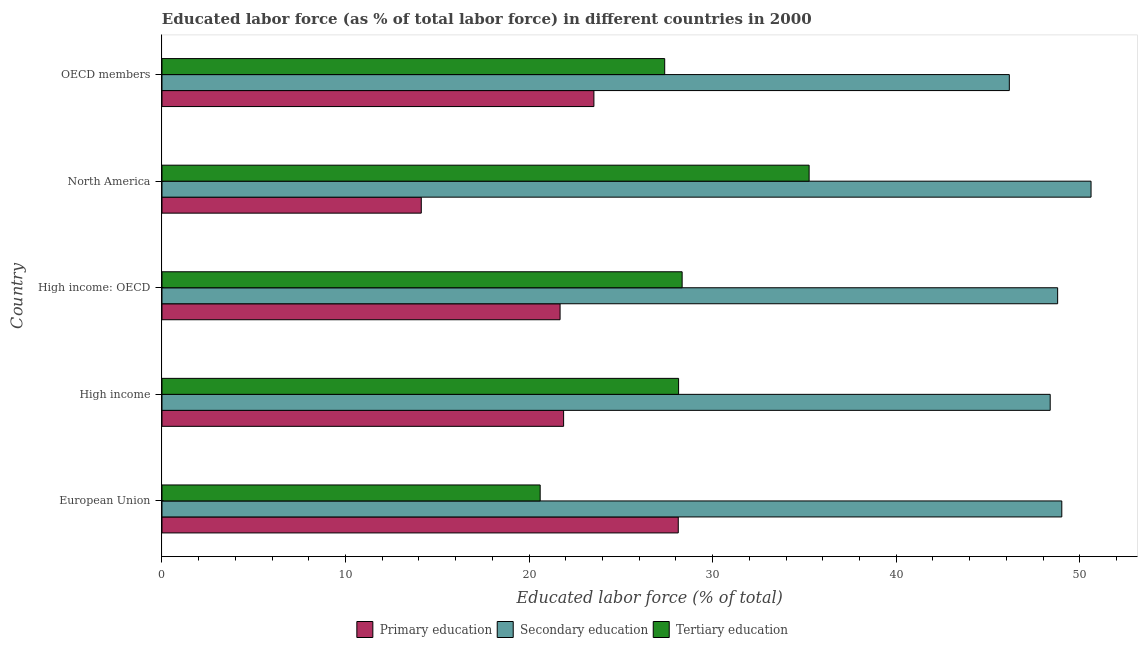How many different coloured bars are there?
Make the answer very short. 3. Are the number of bars per tick equal to the number of legend labels?
Your answer should be very brief. Yes. How many bars are there on the 3rd tick from the bottom?
Provide a short and direct response. 3. What is the percentage of labor force who received secondary education in High income: OECD?
Your response must be concise. 48.8. Across all countries, what is the maximum percentage of labor force who received primary education?
Ensure brevity in your answer.  28.13. Across all countries, what is the minimum percentage of labor force who received tertiary education?
Offer a terse response. 20.6. In which country was the percentage of labor force who received primary education minimum?
Offer a terse response. North America. What is the total percentage of labor force who received tertiary education in the graph?
Give a very brief answer. 139.73. What is the difference between the percentage of labor force who received tertiary education in European Union and that in North America?
Offer a very short reply. -14.65. What is the difference between the percentage of labor force who received secondary education in High income: OECD and the percentage of labor force who received primary education in OECD members?
Your response must be concise. 25.27. What is the average percentage of labor force who received primary education per country?
Offer a terse response. 21.87. What is the difference between the percentage of labor force who received primary education and percentage of labor force who received secondary education in North America?
Provide a succinct answer. -36.49. What is the ratio of the percentage of labor force who received tertiary education in High income to that in OECD members?
Provide a succinct answer. 1.03. Is the percentage of labor force who received secondary education in High income less than that in North America?
Your response must be concise. Yes. What is the difference between the highest and the second highest percentage of labor force who received tertiary education?
Your response must be concise. 6.92. What is the difference between the highest and the lowest percentage of labor force who received secondary education?
Give a very brief answer. 4.45. In how many countries, is the percentage of labor force who received secondary education greater than the average percentage of labor force who received secondary education taken over all countries?
Your response must be concise. 3. Is the sum of the percentage of labor force who received tertiary education in European Union and High income: OECD greater than the maximum percentage of labor force who received primary education across all countries?
Provide a succinct answer. Yes. What does the 2nd bar from the top in High income: OECD represents?
Ensure brevity in your answer.  Secondary education. What does the 3rd bar from the bottom in OECD members represents?
Keep it short and to the point. Tertiary education. How many bars are there?
Keep it short and to the point. 15. How many countries are there in the graph?
Keep it short and to the point. 5. Does the graph contain grids?
Your answer should be very brief. No. Where does the legend appear in the graph?
Your answer should be compact. Bottom center. How are the legend labels stacked?
Ensure brevity in your answer.  Horizontal. What is the title of the graph?
Ensure brevity in your answer.  Educated labor force (as % of total labor force) in different countries in 2000. What is the label or title of the X-axis?
Ensure brevity in your answer.  Educated labor force (% of total). What is the Educated labor force (% of total) in Primary education in European Union?
Offer a very short reply. 28.13. What is the Educated labor force (% of total) of Secondary education in European Union?
Provide a succinct answer. 49.02. What is the Educated labor force (% of total) of Tertiary education in European Union?
Offer a terse response. 20.6. What is the Educated labor force (% of total) of Primary education in High income?
Give a very brief answer. 21.88. What is the Educated labor force (% of total) in Secondary education in High income?
Offer a very short reply. 48.39. What is the Educated labor force (% of total) of Tertiary education in High income?
Your answer should be compact. 28.15. What is the Educated labor force (% of total) in Primary education in High income: OECD?
Your answer should be very brief. 21.69. What is the Educated labor force (% of total) of Secondary education in High income: OECD?
Offer a very short reply. 48.8. What is the Educated labor force (% of total) of Tertiary education in High income: OECD?
Give a very brief answer. 28.34. What is the Educated labor force (% of total) of Primary education in North America?
Your response must be concise. 14.13. What is the Educated labor force (% of total) in Secondary education in North America?
Your answer should be very brief. 50.62. What is the Educated labor force (% of total) of Tertiary education in North America?
Offer a terse response. 35.26. What is the Educated labor force (% of total) in Primary education in OECD members?
Offer a very short reply. 23.53. What is the Educated labor force (% of total) in Secondary education in OECD members?
Keep it short and to the point. 46.16. What is the Educated labor force (% of total) of Tertiary education in OECD members?
Keep it short and to the point. 27.39. Across all countries, what is the maximum Educated labor force (% of total) in Primary education?
Make the answer very short. 28.13. Across all countries, what is the maximum Educated labor force (% of total) of Secondary education?
Your answer should be very brief. 50.62. Across all countries, what is the maximum Educated labor force (% of total) of Tertiary education?
Your response must be concise. 35.26. Across all countries, what is the minimum Educated labor force (% of total) in Primary education?
Give a very brief answer. 14.13. Across all countries, what is the minimum Educated labor force (% of total) in Secondary education?
Provide a succinct answer. 46.16. Across all countries, what is the minimum Educated labor force (% of total) of Tertiary education?
Provide a succinct answer. 20.6. What is the total Educated labor force (% of total) in Primary education in the graph?
Your response must be concise. 109.36. What is the total Educated labor force (% of total) in Secondary education in the graph?
Your answer should be very brief. 242.99. What is the total Educated labor force (% of total) of Tertiary education in the graph?
Keep it short and to the point. 139.73. What is the difference between the Educated labor force (% of total) in Primary education in European Union and that in High income?
Your response must be concise. 6.25. What is the difference between the Educated labor force (% of total) in Secondary education in European Union and that in High income?
Give a very brief answer. 0.63. What is the difference between the Educated labor force (% of total) in Tertiary education in European Union and that in High income?
Offer a terse response. -7.54. What is the difference between the Educated labor force (% of total) in Primary education in European Union and that in High income: OECD?
Offer a terse response. 6.44. What is the difference between the Educated labor force (% of total) in Secondary education in European Union and that in High income: OECD?
Your response must be concise. 0.23. What is the difference between the Educated labor force (% of total) in Tertiary education in European Union and that in High income: OECD?
Offer a very short reply. -7.73. What is the difference between the Educated labor force (% of total) in Primary education in European Union and that in North America?
Provide a short and direct response. 14. What is the difference between the Educated labor force (% of total) in Secondary education in European Union and that in North America?
Offer a terse response. -1.59. What is the difference between the Educated labor force (% of total) in Tertiary education in European Union and that in North America?
Give a very brief answer. -14.65. What is the difference between the Educated labor force (% of total) in Primary education in European Union and that in OECD members?
Provide a succinct answer. 4.6. What is the difference between the Educated labor force (% of total) of Secondary education in European Union and that in OECD members?
Provide a short and direct response. 2.86. What is the difference between the Educated labor force (% of total) in Tertiary education in European Union and that in OECD members?
Give a very brief answer. -6.78. What is the difference between the Educated labor force (% of total) of Primary education in High income and that in High income: OECD?
Your response must be concise. 0.19. What is the difference between the Educated labor force (% of total) in Secondary education in High income and that in High income: OECD?
Offer a very short reply. -0.41. What is the difference between the Educated labor force (% of total) of Tertiary education in High income and that in High income: OECD?
Offer a very short reply. -0.19. What is the difference between the Educated labor force (% of total) of Primary education in High income and that in North America?
Your answer should be very brief. 7.75. What is the difference between the Educated labor force (% of total) in Secondary education in High income and that in North America?
Keep it short and to the point. -2.23. What is the difference between the Educated labor force (% of total) of Tertiary education in High income and that in North America?
Provide a succinct answer. -7.11. What is the difference between the Educated labor force (% of total) in Primary education in High income and that in OECD members?
Give a very brief answer. -1.65. What is the difference between the Educated labor force (% of total) of Secondary education in High income and that in OECD members?
Give a very brief answer. 2.23. What is the difference between the Educated labor force (% of total) in Tertiary education in High income and that in OECD members?
Your answer should be compact. 0.76. What is the difference between the Educated labor force (% of total) in Primary education in High income: OECD and that in North America?
Your answer should be compact. 7.56. What is the difference between the Educated labor force (% of total) of Secondary education in High income: OECD and that in North America?
Your answer should be compact. -1.82. What is the difference between the Educated labor force (% of total) in Tertiary education in High income: OECD and that in North America?
Offer a terse response. -6.92. What is the difference between the Educated labor force (% of total) in Primary education in High income: OECD and that in OECD members?
Your answer should be compact. -1.84. What is the difference between the Educated labor force (% of total) of Secondary education in High income: OECD and that in OECD members?
Ensure brevity in your answer.  2.63. What is the difference between the Educated labor force (% of total) in Tertiary education in High income: OECD and that in OECD members?
Keep it short and to the point. 0.95. What is the difference between the Educated labor force (% of total) of Primary education in North America and that in OECD members?
Provide a short and direct response. -9.4. What is the difference between the Educated labor force (% of total) of Secondary education in North America and that in OECD members?
Provide a succinct answer. 4.45. What is the difference between the Educated labor force (% of total) in Tertiary education in North America and that in OECD members?
Give a very brief answer. 7.87. What is the difference between the Educated labor force (% of total) in Primary education in European Union and the Educated labor force (% of total) in Secondary education in High income?
Give a very brief answer. -20.26. What is the difference between the Educated labor force (% of total) of Primary education in European Union and the Educated labor force (% of total) of Tertiary education in High income?
Offer a very short reply. -0.02. What is the difference between the Educated labor force (% of total) of Secondary education in European Union and the Educated labor force (% of total) of Tertiary education in High income?
Keep it short and to the point. 20.88. What is the difference between the Educated labor force (% of total) of Primary education in European Union and the Educated labor force (% of total) of Secondary education in High income: OECD?
Offer a terse response. -20.67. What is the difference between the Educated labor force (% of total) of Primary education in European Union and the Educated labor force (% of total) of Tertiary education in High income: OECD?
Offer a very short reply. -0.21. What is the difference between the Educated labor force (% of total) in Secondary education in European Union and the Educated labor force (% of total) in Tertiary education in High income: OECD?
Your answer should be compact. 20.68. What is the difference between the Educated labor force (% of total) of Primary education in European Union and the Educated labor force (% of total) of Secondary education in North America?
Provide a succinct answer. -22.49. What is the difference between the Educated labor force (% of total) in Primary education in European Union and the Educated labor force (% of total) in Tertiary education in North America?
Your response must be concise. -7.13. What is the difference between the Educated labor force (% of total) of Secondary education in European Union and the Educated labor force (% of total) of Tertiary education in North America?
Offer a terse response. 13.77. What is the difference between the Educated labor force (% of total) of Primary education in European Union and the Educated labor force (% of total) of Secondary education in OECD members?
Provide a short and direct response. -18.04. What is the difference between the Educated labor force (% of total) of Primary education in European Union and the Educated labor force (% of total) of Tertiary education in OECD members?
Ensure brevity in your answer.  0.74. What is the difference between the Educated labor force (% of total) in Secondary education in European Union and the Educated labor force (% of total) in Tertiary education in OECD members?
Your answer should be compact. 21.63. What is the difference between the Educated labor force (% of total) of Primary education in High income and the Educated labor force (% of total) of Secondary education in High income: OECD?
Your answer should be compact. -26.92. What is the difference between the Educated labor force (% of total) in Primary education in High income and the Educated labor force (% of total) in Tertiary education in High income: OECD?
Give a very brief answer. -6.46. What is the difference between the Educated labor force (% of total) of Secondary education in High income and the Educated labor force (% of total) of Tertiary education in High income: OECD?
Offer a very short reply. 20.05. What is the difference between the Educated labor force (% of total) in Primary education in High income and the Educated labor force (% of total) in Secondary education in North America?
Offer a terse response. -28.74. What is the difference between the Educated labor force (% of total) in Primary education in High income and the Educated labor force (% of total) in Tertiary education in North America?
Ensure brevity in your answer.  -13.38. What is the difference between the Educated labor force (% of total) of Secondary education in High income and the Educated labor force (% of total) of Tertiary education in North America?
Give a very brief answer. 13.13. What is the difference between the Educated labor force (% of total) of Primary education in High income and the Educated labor force (% of total) of Secondary education in OECD members?
Provide a succinct answer. -24.28. What is the difference between the Educated labor force (% of total) in Primary education in High income and the Educated labor force (% of total) in Tertiary education in OECD members?
Offer a very short reply. -5.51. What is the difference between the Educated labor force (% of total) in Secondary education in High income and the Educated labor force (% of total) in Tertiary education in OECD members?
Offer a terse response. 21. What is the difference between the Educated labor force (% of total) of Primary education in High income: OECD and the Educated labor force (% of total) of Secondary education in North America?
Offer a very short reply. -28.93. What is the difference between the Educated labor force (% of total) in Primary education in High income: OECD and the Educated labor force (% of total) in Tertiary education in North America?
Make the answer very short. -13.57. What is the difference between the Educated labor force (% of total) in Secondary education in High income: OECD and the Educated labor force (% of total) in Tertiary education in North America?
Your answer should be compact. 13.54. What is the difference between the Educated labor force (% of total) of Primary education in High income: OECD and the Educated labor force (% of total) of Secondary education in OECD members?
Offer a very short reply. -24.48. What is the difference between the Educated labor force (% of total) of Primary education in High income: OECD and the Educated labor force (% of total) of Tertiary education in OECD members?
Provide a succinct answer. -5.7. What is the difference between the Educated labor force (% of total) of Secondary education in High income: OECD and the Educated labor force (% of total) of Tertiary education in OECD members?
Provide a succinct answer. 21.41. What is the difference between the Educated labor force (% of total) in Primary education in North America and the Educated labor force (% of total) in Secondary education in OECD members?
Offer a terse response. -32.04. What is the difference between the Educated labor force (% of total) of Primary education in North America and the Educated labor force (% of total) of Tertiary education in OECD members?
Provide a succinct answer. -13.26. What is the difference between the Educated labor force (% of total) of Secondary education in North America and the Educated labor force (% of total) of Tertiary education in OECD members?
Make the answer very short. 23.23. What is the average Educated labor force (% of total) of Primary education per country?
Your answer should be very brief. 21.87. What is the average Educated labor force (% of total) in Secondary education per country?
Your response must be concise. 48.6. What is the average Educated labor force (% of total) in Tertiary education per country?
Provide a short and direct response. 27.95. What is the difference between the Educated labor force (% of total) of Primary education and Educated labor force (% of total) of Secondary education in European Union?
Provide a short and direct response. -20.9. What is the difference between the Educated labor force (% of total) in Primary education and Educated labor force (% of total) in Tertiary education in European Union?
Provide a succinct answer. 7.52. What is the difference between the Educated labor force (% of total) of Secondary education and Educated labor force (% of total) of Tertiary education in European Union?
Your answer should be compact. 28.42. What is the difference between the Educated labor force (% of total) of Primary education and Educated labor force (% of total) of Secondary education in High income?
Make the answer very short. -26.51. What is the difference between the Educated labor force (% of total) of Primary education and Educated labor force (% of total) of Tertiary education in High income?
Your answer should be very brief. -6.27. What is the difference between the Educated labor force (% of total) in Secondary education and Educated labor force (% of total) in Tertiary education in High income?
Give a very brief answer. 20.25. What is the difference between the Educated labor force (% of total) in Primary education and Educated labor force (% of total) in Secondary education in High income: OECD?
Give a very brief answer. -27.11. What is the difference between the Educated labor force (% of total) of Primary education and Educated labor force (% of total) of Tertiary education in High income: OECD?
Make the answer very short. -6.65. What is the difference between the Educated labor force (% of total) of Secondary education and Educated labor force (% of total) of Tertiary education in High income: OECD?
Ensure brevity in your answer.  20.46. What is the difference between the Educated labor force (% of total) in Primary education and Educated labor force (% of total) in Secondary education in North America?
Keep it short and to the point. -36.49. What is the difference between the Educated labor force (% of total) of Primary education and Educated labor force (% of total) of Tertiary education in North America?
Offer a terse response. -21.13. What is the difference between the Educated labor force (% of total) in Secondary education and Educated labor force (% of total) in Tertiary education in North America?
Offer a terse response. 15.36. What is the difference between the Educated labor force (% of total) of Primary education and Educated labor force (% of total) of Secondary education in OECD members?
Ensure brevity in your answer.  -22.63. What is the difference between the Educated labor force (% of total) of Primary education and Educated labor force (% of total) of Tertiary education in OECD members?
Provide a succinct answer. -3.86. What is the difference between the Educated labor force (% of total) of Secondary education and Educated labor force (% of total) of Tertiary education in OECD members?
Your response must be concise. 18.78. What is the ratio of the Educated labor force (% of total) of Primary education in European Union to that in High income?
Ensure brevity in your answer.  1.29. What is the ratio of the Educated labor force (% of total) of Secondary education in European Union to that in High income?
Keep it short and to the point. 1.01. What is the ratio of the Educated labor force (% of total) of Tertiary education in European Union to that in High income?
Give a very brief answer. 0.73. What is the ratio of the Educated labor force (% of total) of Primary education in European Union to that in High income: OECD?
Provide a short and direct response. 1.3. What is the ratio of the Educated labor force (% of total) in Tertiary education in European Union to that in High income: OECD?
Ensure brevity in your answer.  0.73. What is the ratio of the Educated labor force (% of total) in Primary education in European Union to that in North America?
Provide a succinct answer. 1.99. What is the ratio of the Educated labor force (% of total) of Secondary education in European Union to that in North America?
Your answer should be compact. 0.97. What is the ratio of the Educated labor force (% of total) of Tertiary education in European Union to that in North America?
Ensure brevity in your answer.  0.58. What is the ratio of the Educated labor force (% of total) of Primary education in European Union to that in OECD members?
Offer a terse response. 1.2. What is the ratio of the Educated labor force (% of total) of Secondary education in European Union to that in OECD members?
Offer a very short reply. 1.06. What is the ratio of the Educated labor force (% of total) in Tertiary education in European Union to that in OECD members?
Offer a terse response. 0.75. What is the ratio of the Educated labor force (% of total) of Primary education in High income to that in High income: OECD?
Offer a terse response. 1.01. What is the ratio of the Educated labor force (% of total) in Primary education in High income to that in North America?
Make the answer very short. 1.55. What is the ratio of the Educated labor force (% of total) of Secondary education in High income to that in North America?
Offer a terse response. 0.96. What is the ratio of the Educated labor force (% of total) in Tertiary education in High income to that in North America?
Ensure brevity in your answer.  0.8. What is the ratio of the Educated labor force (% of total) in Primary education in High income to that in OECD members?
Offer a terse response. 0.93. What is the ratio of the Educated labor force (% of total) of Secondary education in High income to that in OECD members?
Offer a very short reply. 1.05. What is the ratio of the Educated labor force (% of total) in Tertiary education in High income to that in OECD members?
Ensure brevity in your answer.  1.03. What is the ratio of the Educated labor force (% of total) of Primary education in High income: OECD to that in North America?
Your response must be concise. 1.54. What is the ratio of the Educated labor force (% of total) in Secondary education in High income: OECD to that in North America?
Provide a succinct answer. 0.96. What is the ratio of the Educated labor force (% of total) in Tertiary education in High income: OECD to that in North America?
Your answer should be compact. 0.8. What is the ratio of the Educated labor force (% of total) of Primary education in High income: OECD to that in OECD members?
Ensure brevity in your answer.  0.92. What is the ratio of the Educated labor force (% of total) in Secondary education in High income: OECD to that in OECD members?
Your response must be concise. 1.06. What is the ratio of the Educated labor force (% of total) in Tertiary education in High income: OECD to that in OECD members?
Offer a terse response. 1.03. What is the ratio of the Educated labor force (% of total) in Primary education in North America to that in OECD members?
Your answer should be very brief. 0.6. What is the ratio of the Educated labor force (% of total) in Secondary education in North America to that in OECD members?
Give a very brief answer. 1.1. What is the ratio of the Educated labor force (% of total) of Tertiary education in North America to that in OECD members?
Provide a succinct answer. 1.29. What is the difference between the highest and the second highest Educated labor force (% of total) of Primary education?
Provide a short and direct response. 4.6. What is the difference between the highest and the second highest Educated labor force (% of total) in Secondary education?
Your answer should be compact. 1.59. What is the difference between the highest and the second highest Educated labor force (% of total) of Tertiary education?
Offer a terse response. 6.92. What is the difference between the highest and the lowest Educated labor force (% of total) of Primary education?
Offer a very short reply. 14. What is the difference between the highest and the lowest Educated labor force (% of total) of Secondary education?
Your answer should be very brief. 4.45. What is the difference between the highest and the lowest Educated labor force (% of total) of Tertiary education?
Your answer should be very brief. 14.65. 